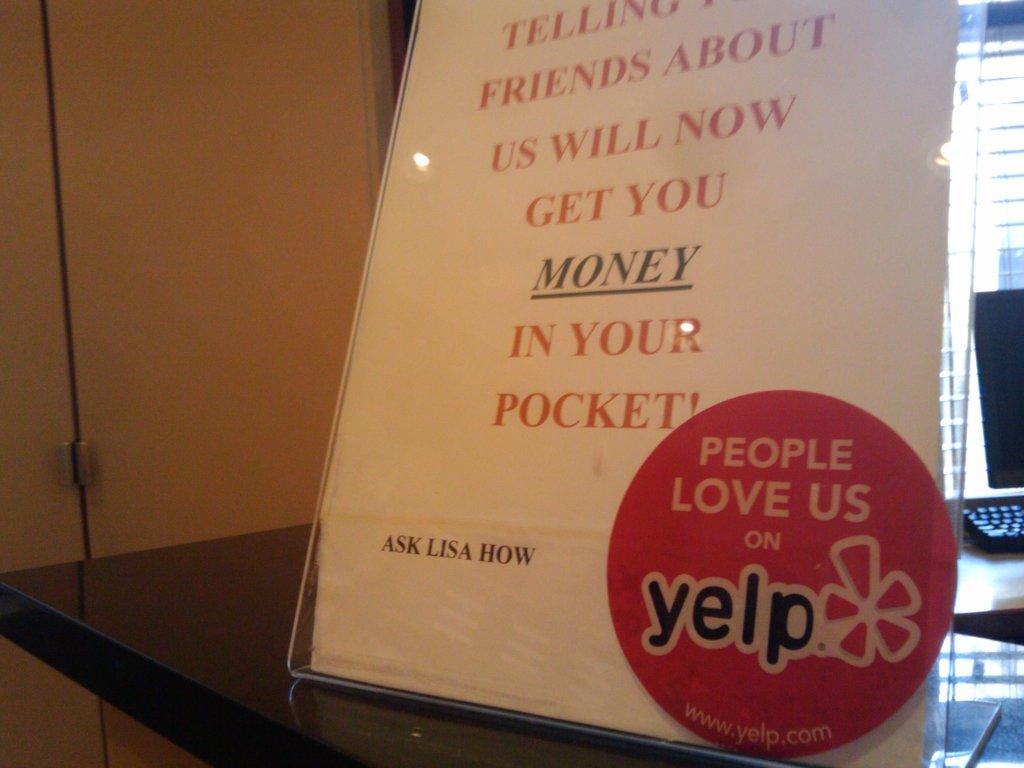What do people love according to the sticker?
Your response must be concise. Us. What does the sign says goes into your pocket?
Your answer should be very brief. Money. 